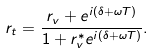Convert formula to latex. <formula><loc_0><loc_0><loc_500><loc_500>r _ { t } = \frac { r _ { v } + e ^ { i ( \delta + \omega T ) } } { 1 + r _ { v } ^ { * } e ^ { i ( \delta + \omega T ) } } .</formula> 